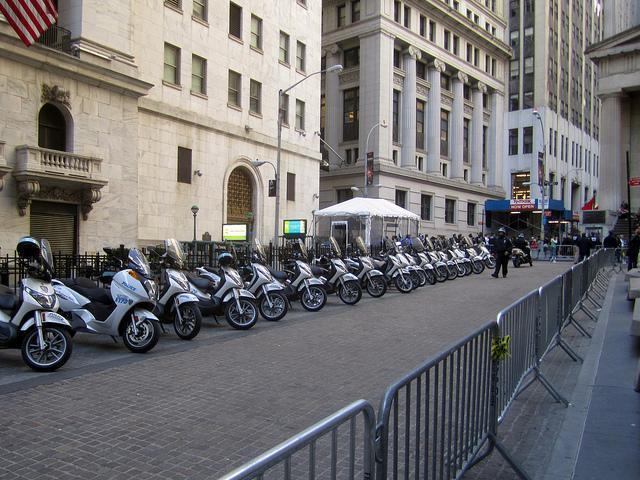How many motorcycles are in the picture?
Give a very brief answer. 6. 